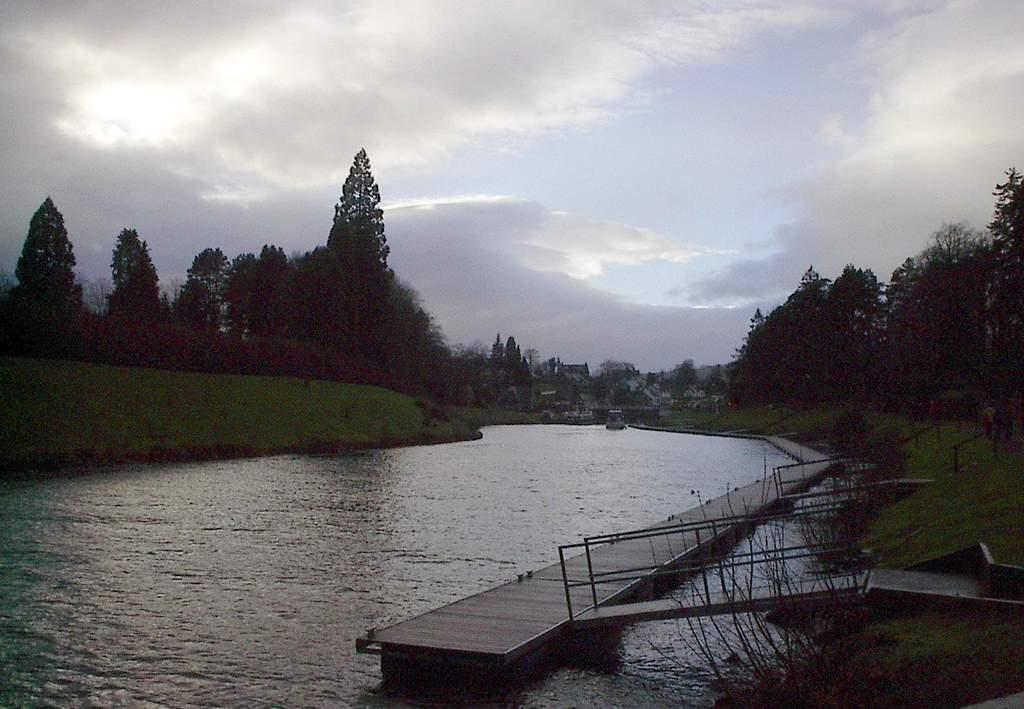What is the main feature in the center of the image? There is water in the center of the image. What type of structure is present in the image? There is a bridge with stairs in the image. What can be seen in the background of the image? There are trees and buildings in the background of the image. What is visible in the sky at the top of the image? There are clouds visible in the sky at the top of the image. Where is the window located in the image? There is no window present in the image. What type of bag can be seen hanging from the bridge in the image? There is no bag hanging from the bridge in the image. 